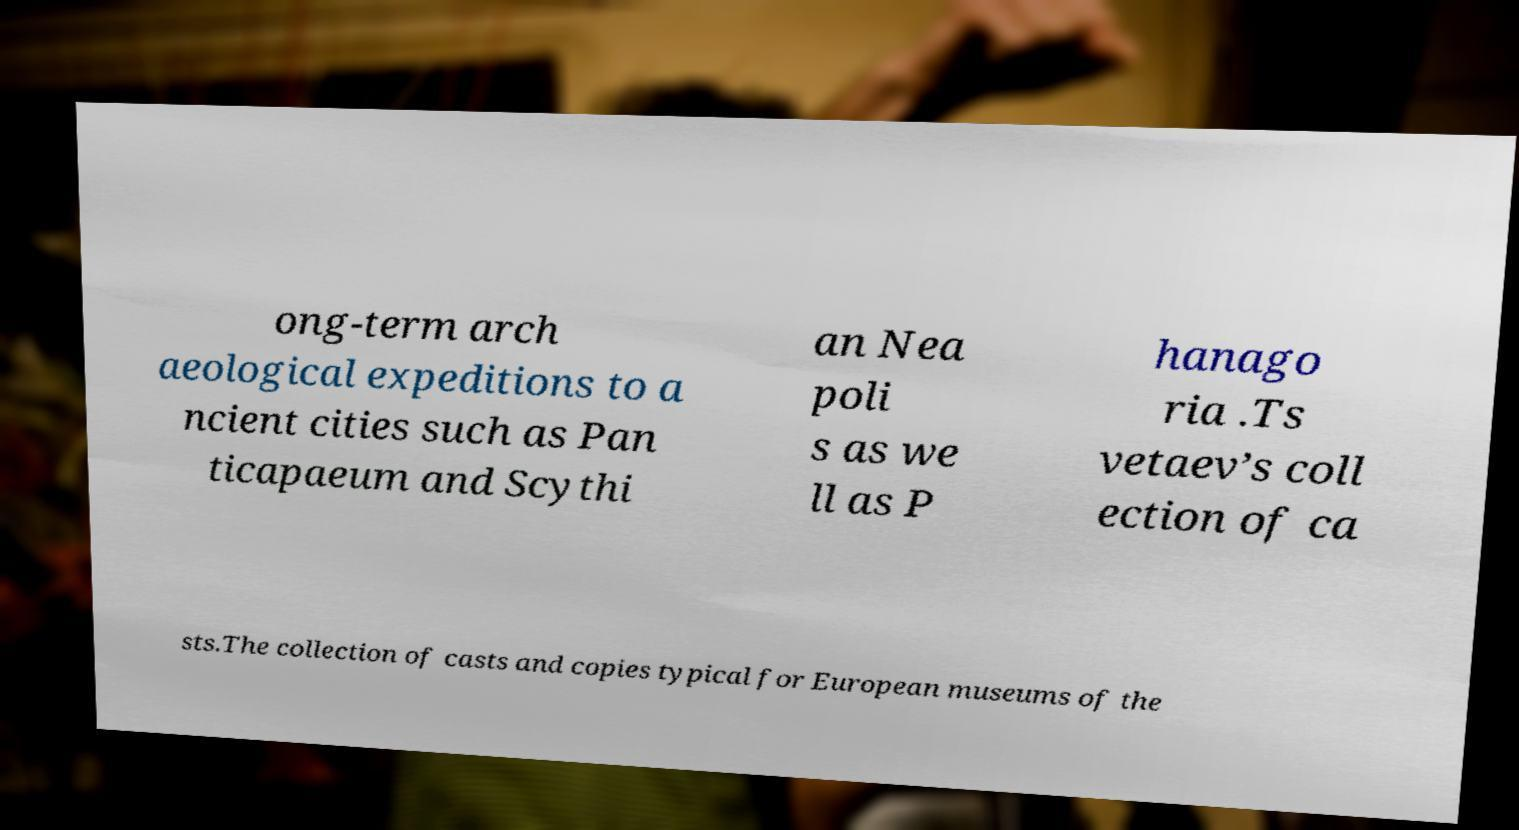Could you assist in decoding the text presented in this image and type it out clearly? ong-term arch aeological expeditions to a ncient cities such as Pan ticapaeum and Scythi an Nea poli s as we ll as P hanago ria .Ts vetaev’s coll ection of ca sts.The collection of casts and copies typical for European museums of the 